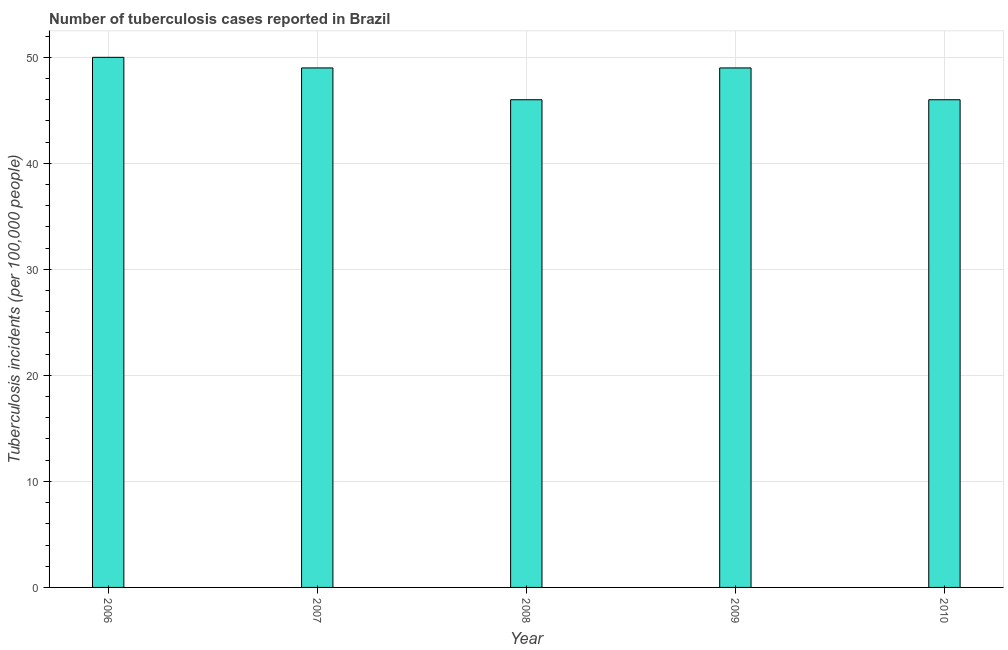What is the title of the graph?
Provide a succinct answer. Number of tuberculosis cases reported in Brazil. What is the label or title of the X-axis?
Your answer should be compact. Year. What is the label or title of the Y-axis?
Keep it short and to the point. Tuberculosis incidents (per 100,0 people). In which year was the number of tuberculosis incidents maximum?
Your response must be concise. 2006. In which year was the number of tuberculosis incidents minimum?
Offer a terse response. 2008. What is the sum of the number of tuberculosis incidents?
Your answer should be compact. 240. What is the difference between the number of tuberculosis incidents in 2008 and 2010?
Offer a very short reply. 0. What is the median number of tuberculosis incidents?
Your response must be concise. 49. What is the ratio of the number of tuberculosis incidents in 2007 to that in 2010?
Ensure brevity in your answer.  1.06. Is the number of tuberculosis incidents in 2008 less than that in 2010?
Provide a succinct answer. No. What is the difference between the highest and the lowest number of tuberculosis incidents?
Give a very brief answer. 4. Are all the bars in the graph horizontal?
Make the answer very short. No. What is the Tuberculosis incidents (per 100,000 people) in 2007?
Provide a short and direct response. 49. What is the Tuberculosis incidents (per 100,000 people) in 2008?
Your response must be concise. 46. What is the Tuberculosis incidents (per 100,000 people) in 2009?
Give a very brief answer. 49. What is the difference between the Tuberculosis incidents (per 100,000 people) in 2006 and 2007?
Make the answer very short. 1. What is the difference between the Tuberculosis incidents (per 100,000 people) in 2006 and 2009?
Ensure brevity in your answer.  1. What is the difference between the Tuberculosis incidents (per 100,000 people) in 2006 and 2010?
Make the answer very short. 4. What is the difference between the Tuberculosis incidents (per 100,000 people) in 2007 and 2008?
Provide a succinct answer. 3. What is the difference between the Tuberculosis incidents (per 100,000 people) in 2008 and 2010?
Provide a short and direct response. 0. What is the ratio of the Tuberculosis incidents (per 100,000 people) in 2006 to that in 2008?
Keep it short and to the point. 1.09. What is the ratio of the Tuberculosis incidents (per 100,000 people) in 2006 to that in 2009?
Your answer should be compact. 1.02. What is the ratio of the Tuberculosis incidents (per 100,000 people) in 2006 to that in 2010?
Your answer should be very brief. 1.09. What is the ratio of the Tuberculosis incidents (per 100,000 people) in 2007 to that in 2008?
Ensure brevity in your answer.  1.06. What is the ratio of the Tuberculosis incidents (per 100,000 people) in 2007 to that in 2010?
Provide a short and direct response. 1.06. What is the ratio of the Tuberculosis incidents (per 100,000 people) in 2008 to that in 2009?
Keep it short and to the point. 0.94. What is the ratio of the Tuberculosis incidents (per 100,000 people) in 2009 to that in 2010?
Keep it short and to the point. 1.06. 